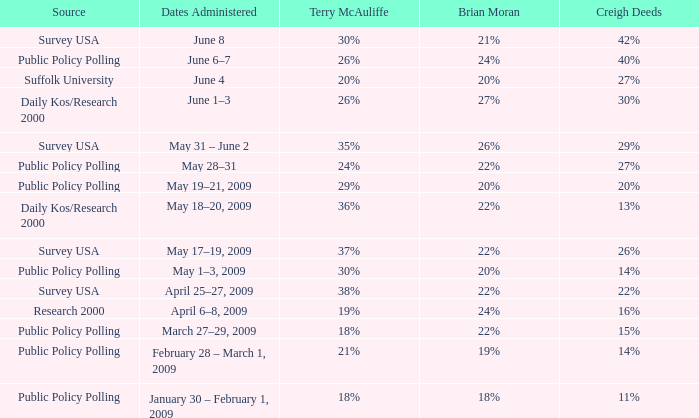Which Terry McAuliffe is it that has a Dates Administered on June 6–7? 26%. 